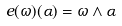<formula> <loc_0><loc_0><loc_500><loc_500>e ( \omega ) ( \alpha ) = \omega \wedge \alpha</formula> 